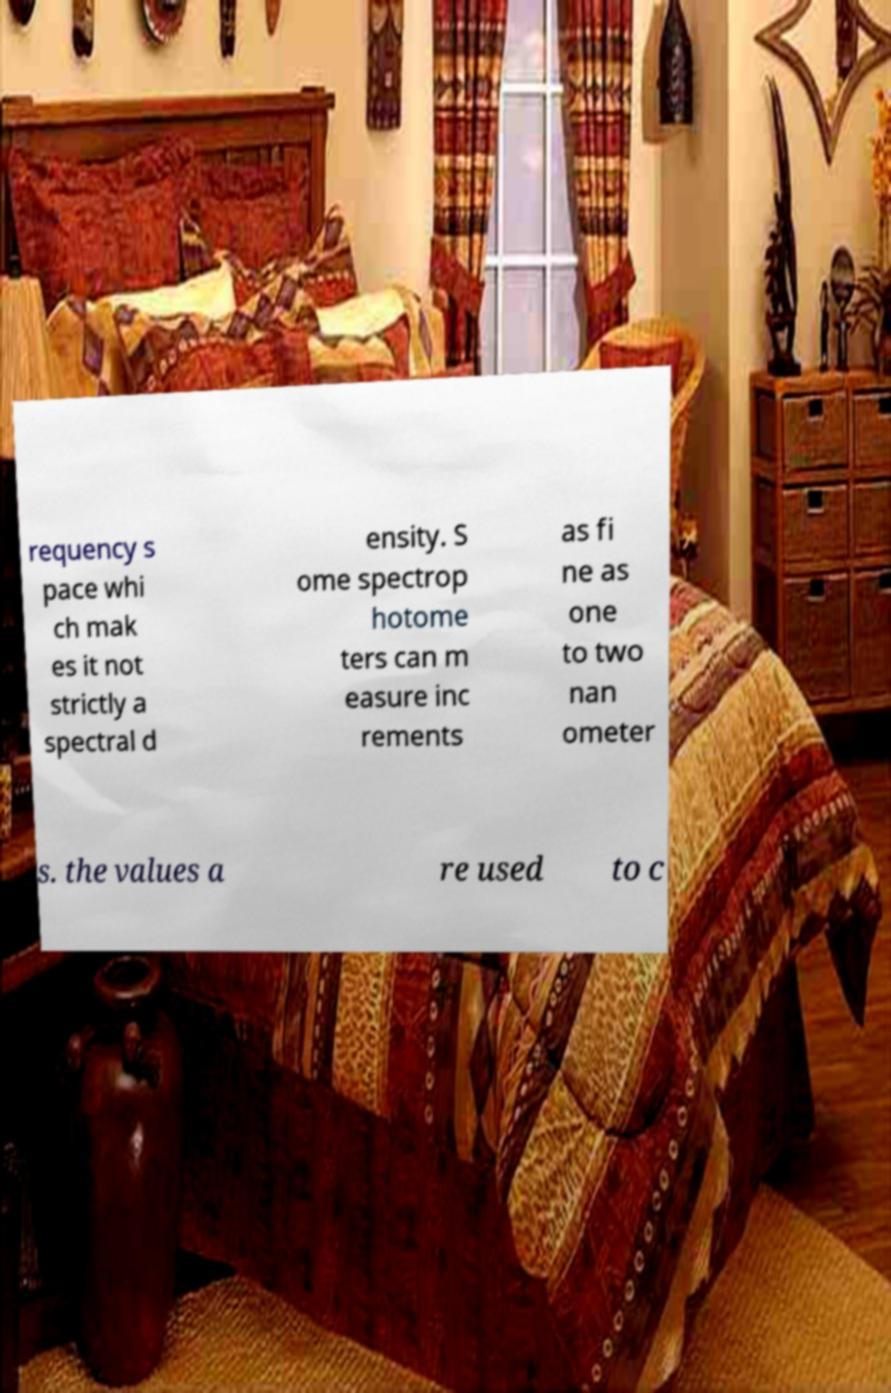What messages or text are displayed in this image? I need them in a readable, typed format. requency s pace whi ch mak es it not strictly a spectral d ensity. S ome spectrop hotome ters can m easure inc rements as fi ne as one to two nan ometer s. the values a re used to c 